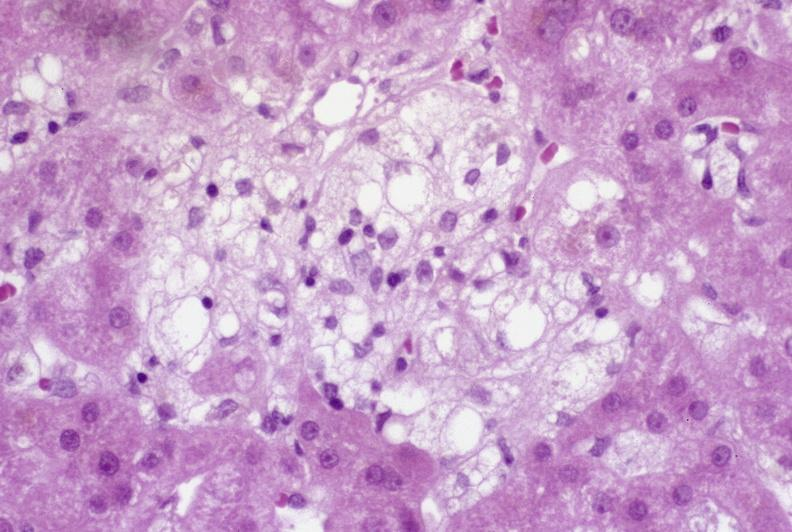does this image show recovery of ducts?
Answer the question using a single word or phrase. Yes 